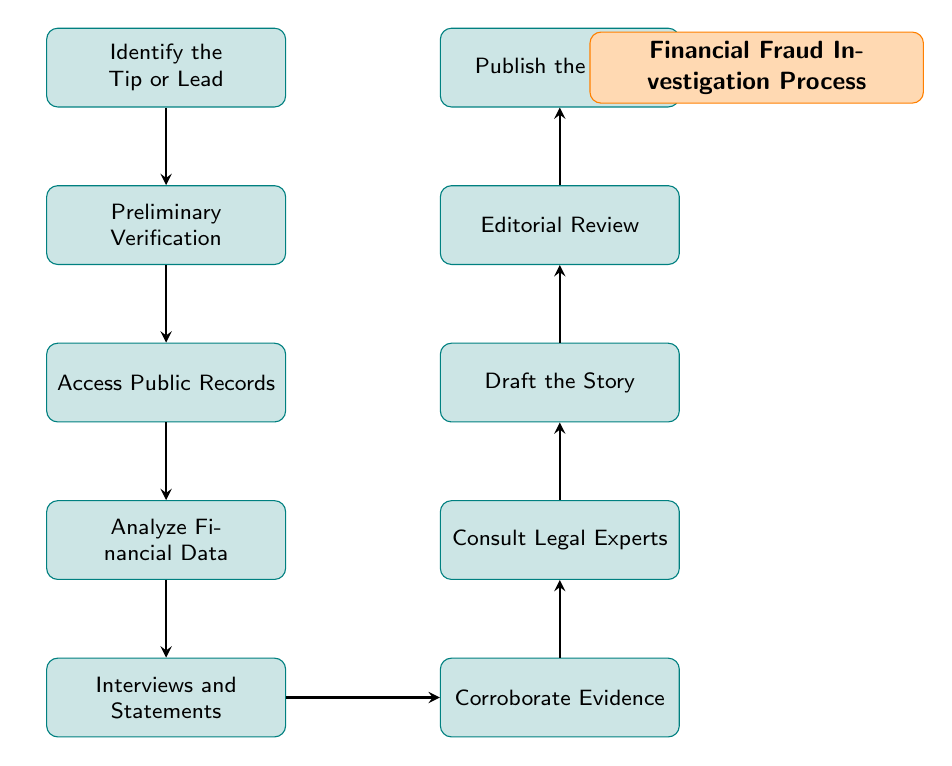What is the first step in the process? The first step is indicated at the top of the diagram and is labeled "Identify the Tip or Lead." This is the starting point for the financial fraud investigation process.
Answer: Identify the Tip or Lead How many total nodes are in the diagram? To find the number of nodes, we count the individual process steps represented in the diagram. There are 10 distinct nodes listed, each representing a step in the investigation process.
Answer: 10 Which step follows "Access Public Records"? By examining the flow of the diagram, we see that "Analyze Financial Data" is directly below "Access Public Records," indicating that it is the subsequent step in the process.
Answer: Analyze Financial Data What is the last step depicted in the process? The last step is represented at the top of the pyramid in the diagram, labeled "Publish the Story." It signifies the final action taken after all preliminary steps are concluded.
Answer: Publish the Story Which two nodes are directly connected by an arrow? "Corroborate Evidence" and "Consult Legal Experts" are connected by an arrow showing the flow from corroboration of evidence to legal consultation in the investigation process.
Answer: Corroborate Evidence & Consult Legal Experts What is the primary purpose of the node "Draft the Story"? The description for this node indicates that its purpose is to compile verified information and create a coherent narrative about the financial fraud, making it a crucial step for documentation.
Answer: Compile verified information Which step requires communication with experts? The node "Consult Legal Experts" specifically mentions discussing findings with legal experts, making it clear that this step involves expert communication.
Answer: Consult Legal Experts What type of information is gathered during "Interviews and Statements"? This step focuses on in-depth information gathering from insiders and relevant sources, emphasizing its role in collecting qualitative data for the investigation.
Answer: In-depth information What step ensures that the investigation complies with laws? The node "Consult Legal Experts" directly addresses the need to understand legal implications and compliance in relation to the investigation findings.
Answer: Consult Legal Experts 